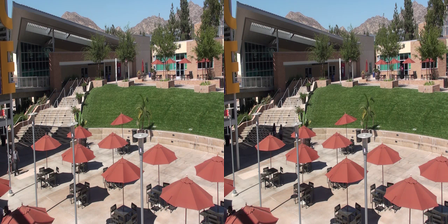You are provided with an image which contains two pictures side by side. Your task is to identify the differences between the two pictures. Separate the differences with a comma. The key differences between the two images include: on the left image, there is one lesser table visible on the patio compared to the right. The right image features an additional tree visible on the mountain range not seen in the left image. Observing the buildings, the left image lacks one window that is present on the building in the right image. Regarding the umbrellas, an additional red stripe is noticeable on one of the umbrellas in the right image that is absent in the left. The staircase handrail in the left image appears incomplete, missing a segment that is present in the right image. Moreover, there is a noticeable person walking on the stairs in the right image that is absent from the left. Finally, a distinct shadow is cast on the building in the left image, not observed on the right, and a bird can be seen flying in the sky in the right image but not in the left. 